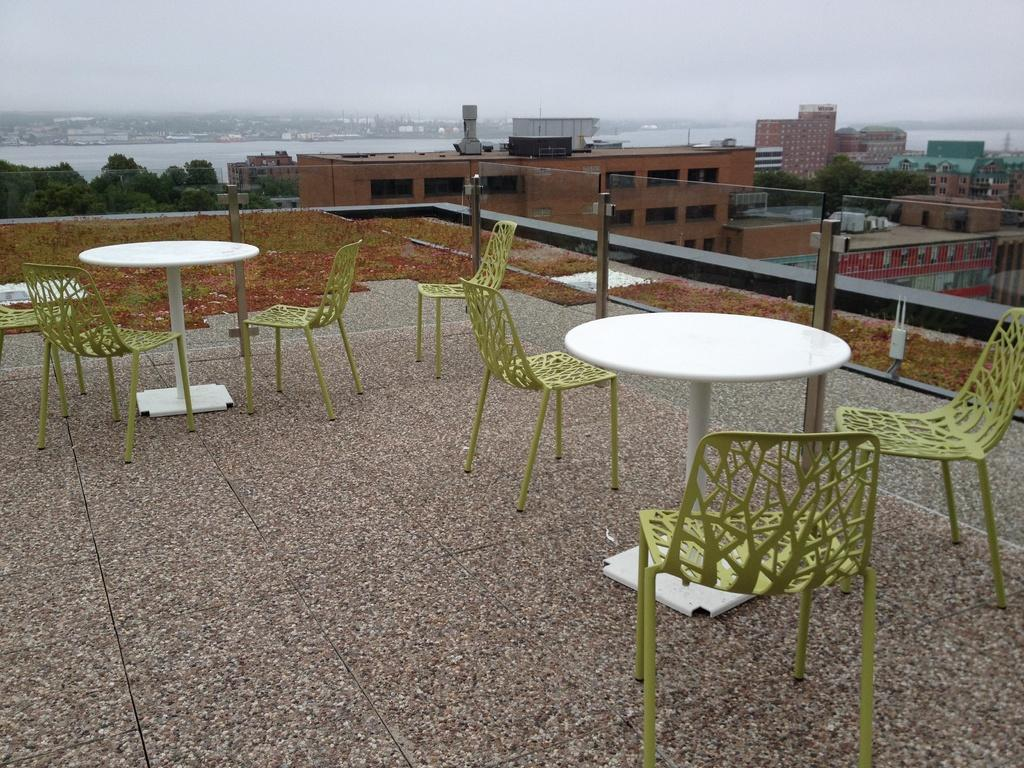What type of furniture can be seen in the image? There are chairs in the image. What type of structures are visible in the image? There are buildings in the image. What type of vegetation is present in the image? There are trees in the image. What natural element is visible in the image? There is water visible in the image. What part of the natural environment is visible in the image? The sky is visible in the image. Where is the bucket located in the image? There is no bucket present in the image. What type of list is visible in the image? There is no list present in the image. 